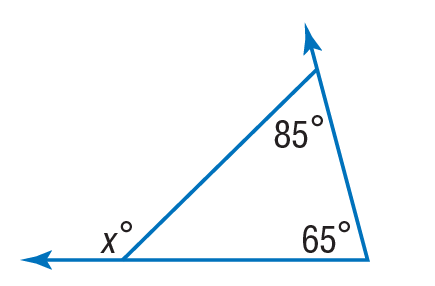Answer the mathemtical geometry problem and directly provide the correct option letter.
Question: Find x to the nearest tenth.
Choices: A: 20 B: 65 C: 85 D: 150 D 